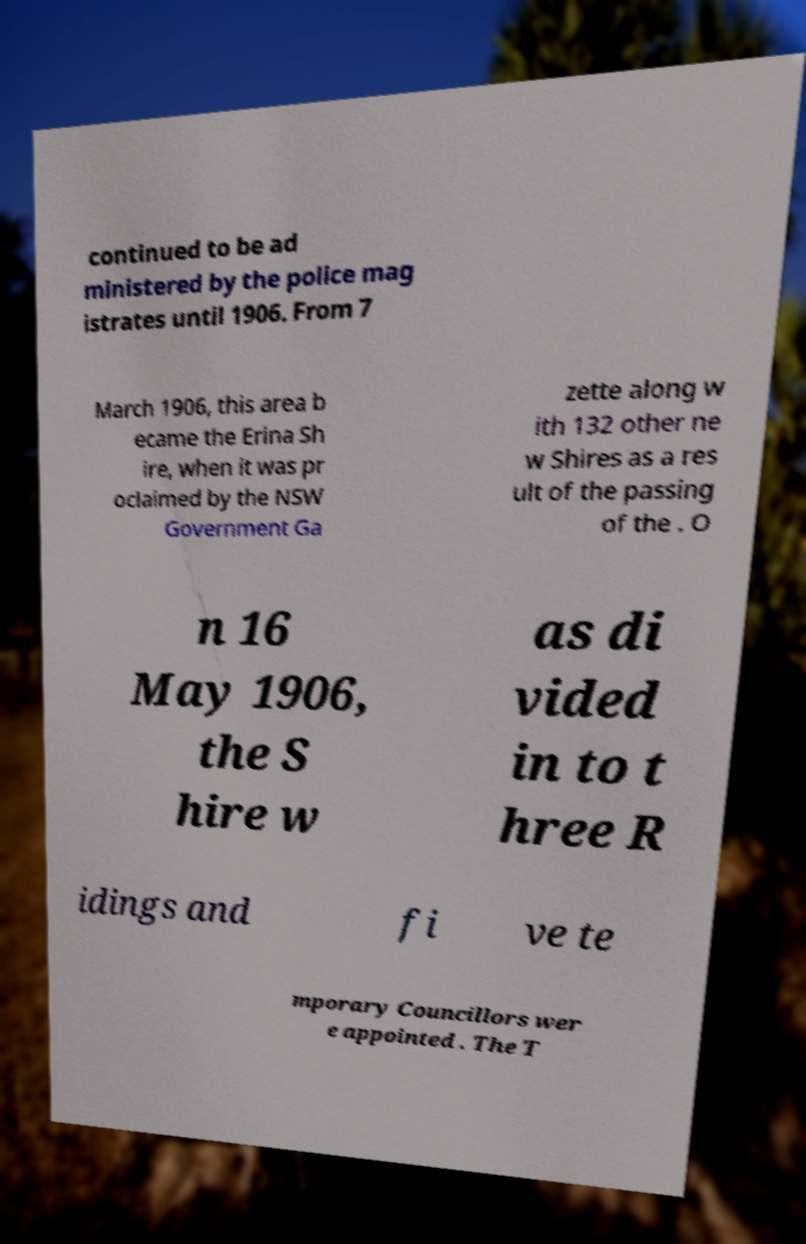What messages or text are displayed in this image? I need them in a readable, typed format. continued to be ad ministered by the police mag istrates until 1906. From 7 March 1906, this area b ecame the Erina Sh ire, when it was pr oclaimed by the NSW Government Ga zette along w ith 132 other ne w Shires as a res ult of the passing of the . O n 16 May 1906, the S hire w as di vided in to t hree R idings and fi ve te mporary Councillors wer e appointed . The T 